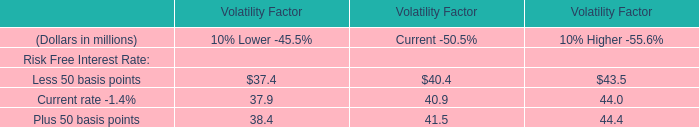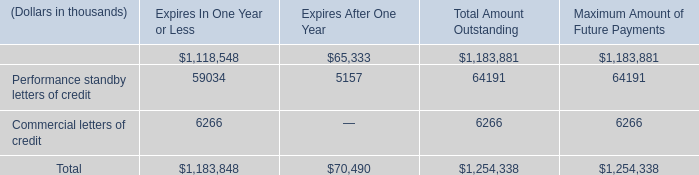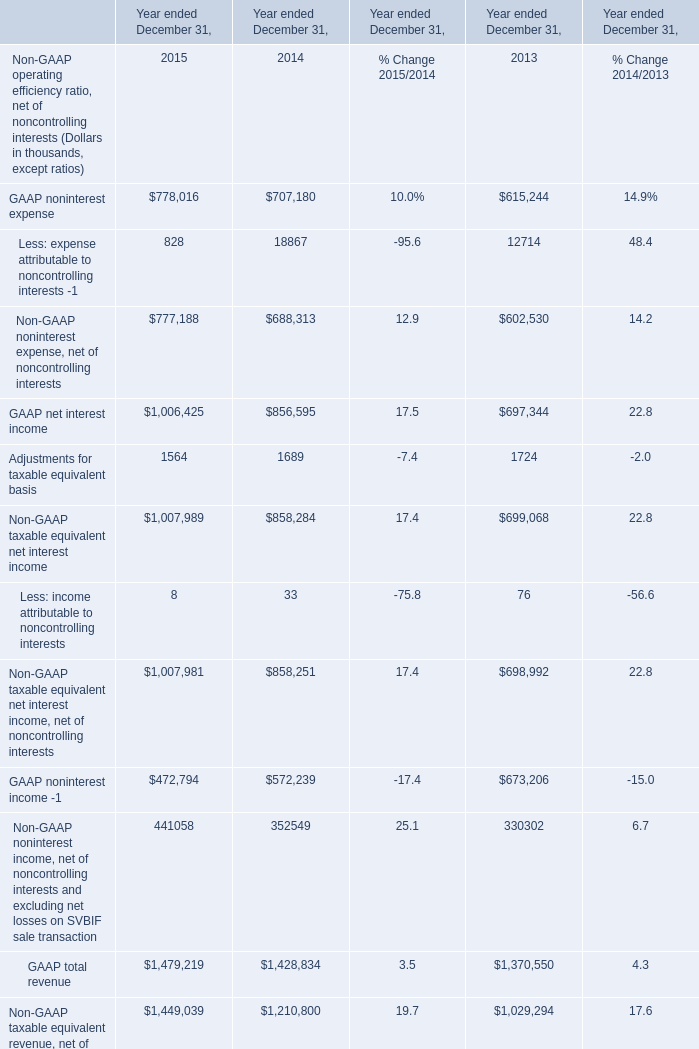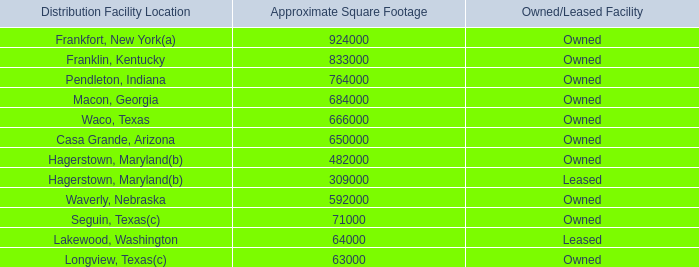In the year with largest amount of GAAP noninterest expense, what's the increasing rate of GAAP net interest income ? 
Computations: ((1006425 - 856595) / 1006425)
Answer: 0.14887. 